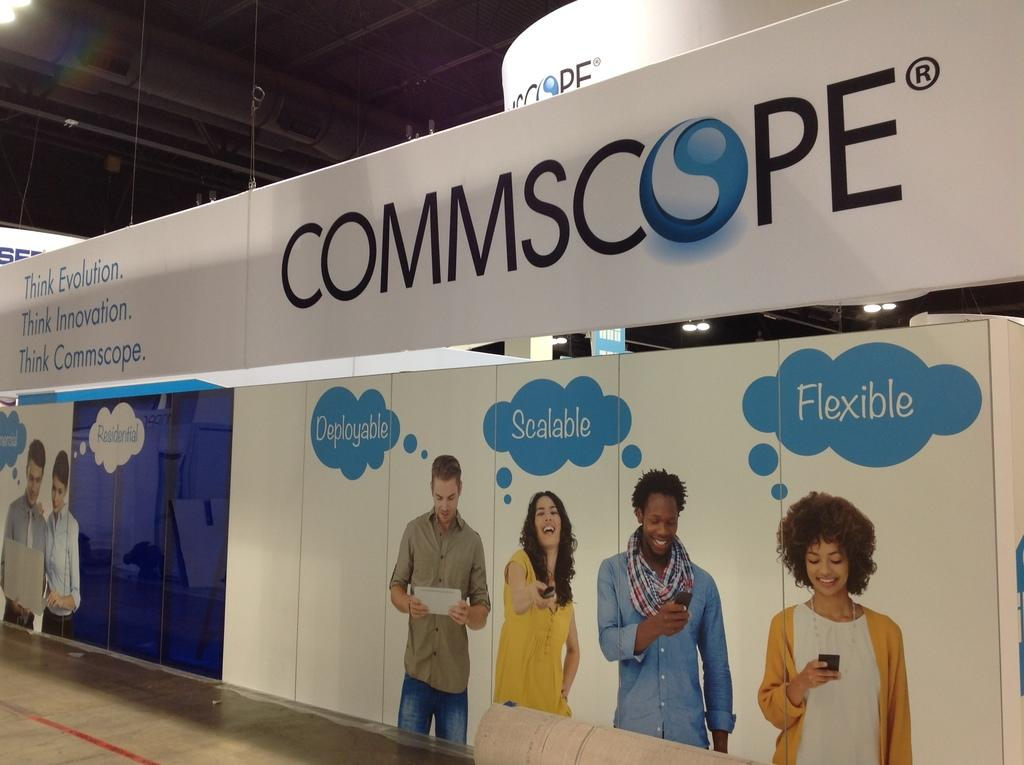What is the primary surface visible in the image? There is a floor in the image. What else can be seen on the floor? There are boards with people in the image. What is written or depicted on the boards? There is text on the boards. What architectural feature is visible in the background of the image? There is a roof visible in the background of the image. Can you tell me how many pages are in the book on the seashore in the image? There is no book or seashore present in the image; it features a floor with boards and people. What type of line is connecting the people on the boards in the image? There is no line connecting the people on the boards in the image; they are simply standing on the boards. 